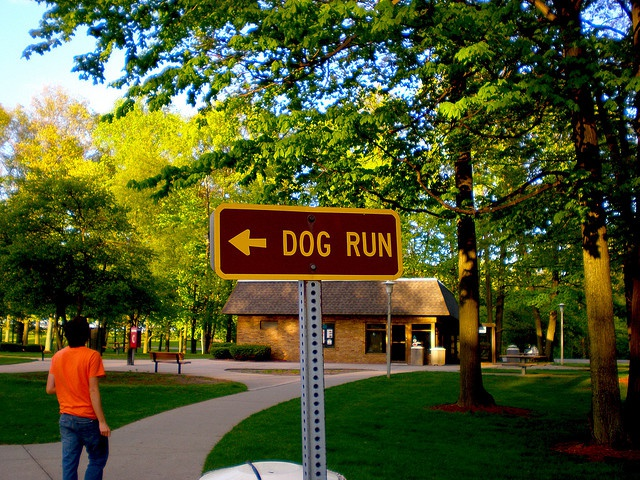Describe the objects in this image and their specific colors. I can see people in lightblue, black, red, and navy tones and bench in lightblue, maroon, black, and gray tones in this image. 